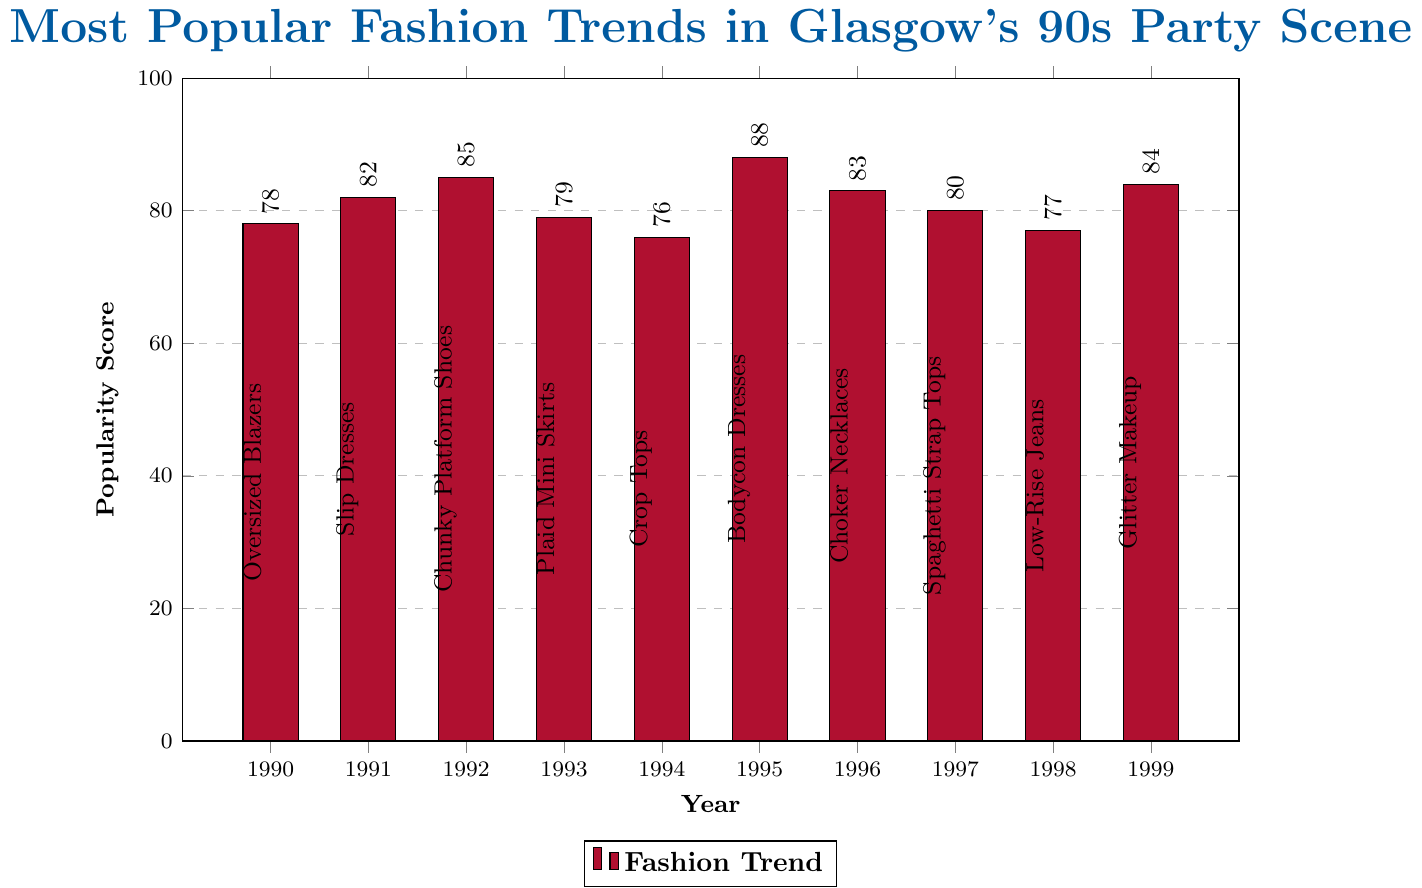Which fashion trend had the highest popularity score in the 90s party scene in Glasgow? By looking at the figure, we see that the highest bar corresponds to Bodycon Dresses in 1995 with a score of 88.
Answer: Bodycon Dresses What was the popularity score difference between Slip Dresses (1991) and Glitter Makeup (1999)? Slip Dresses had a score of 82 and Glitter Makeup had a score of 84. The difference is 84 - 82 = 2.
Answer: 2 Which fashion trends had popularity scores above 80? Looking at the figure, the trends with popularity scores above 80 are Slip Dresses (1991), Chunky Platform Shoes (1992), Bodycon Dresses (1995), Choker Necklaces (1996), and Glitter Makeup (1999).
Answer: Slip Dresses, Chunky Platform Shoes, Bodycon Dresses, Choker Necklaces, Glitter Makeup Which year had the least popular trend and what was the trend? The shortest bar represents Crop Tops in 1994 with a score of 76.
Answer: 1994, Crop Tops Compare the popularity score of Spaghetti Strap Tops (1997) to that of Low-Rise Jeans (1998). Which one was more popular? Spaghetti Strap Tops in 1997 had a score of 80 and Low-Rise Jeans in 1998 had a score of 77. Since 80 > 77, Spaghetti Strap Tops were more popular.
Answer: Spaghetti Strap Tops What is the average popularity score of the fashion trends from 1990 to 1999? Sum of popularity scores: 78+82+85+79+76+88+83+80+77+84 = 812. Number of trends = 10. Average = 812 / 10 = 81.2.
Answer: 81.2 What is the difference in popularity scores between the most popular and the least popular trends? The most popular trend is Bodycon Dresses (1995) with a score of 88, and the least popular is Crop Tops (1994) with a score of 76. The difference is 88 - 76 = 12.
Answer: 12 In what year were Chunky Platform Shoes the most popular fashion trend? Chunky Platform Shoes were the most popular in 1992 with a score of 85.
Answer: 1992 Which trend has a closer popularity score to Plaid Mini Skirts (1993): Crop Tops (1994) or Glitter Makeup (1999)? Plaid Mini Skirts in 1993 had a score of 79, Crop Tops in 1994 had a score of 76, and Glitter Makeup in 1999 had a score of 84. The differences are 79 - 76 = 3 for Crop Tops and 84 - 79 = 5 for Glitter Makeup. Crop Tops are closer.
Answer: Crop Tops 